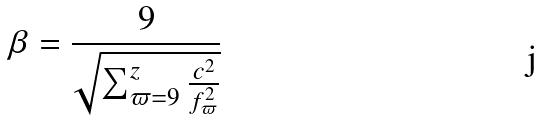Convert formula to latex. <formula><loc_0><loc_0><loc_500><loc_500>\beta = \frac { 9 } { \sqrt { \sum _ { \varpi = 9 } ^ { z } \frac { c ^ { 2 } } { f _ { \varpi } ^ { 2 } } } }</formula> 